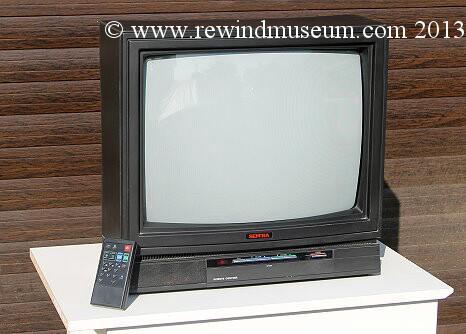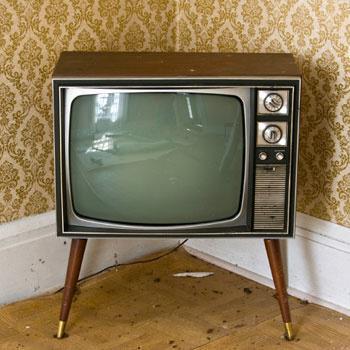The first image is the image on the left, the second image is the image on the right. Given the left and right images, does the statement "One of the televisions is not the console type." hold true? Answer yes or no. Yes. The first image is the image on the left, the second image is the image on the right. Examine the images to the left and right. Is the description "An image shows an old-fashioned wood-cased TV set elevated off the ground on some type of legs." accurate? Answer yes or no. Yes. 